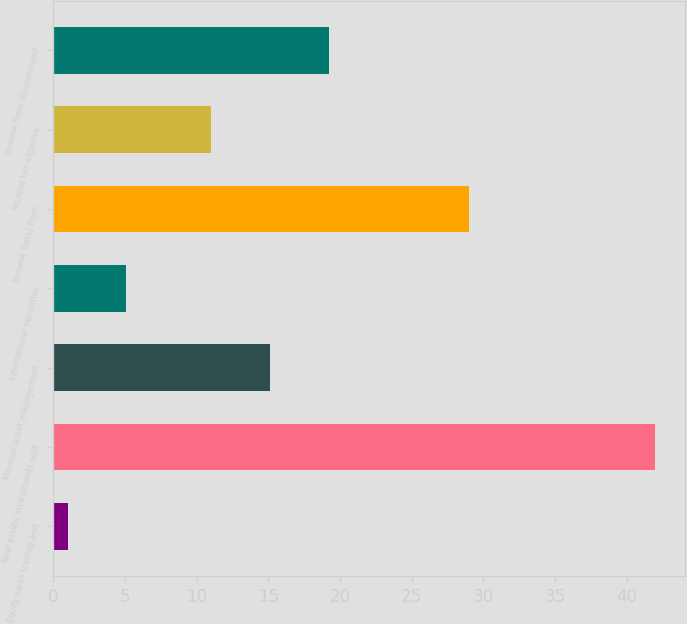Convert chart. <chart><loc_0><loc_0><loc_500><loc_500><bar_chart><fcel>Equity sales trading and<fcel>Real estate investments sold<fcel>Mexican asset management<fcel>International securities<fcel>Income (loss) from<fcel>Income tax expense<fcel>Income from discontinued<nl><fcel>1<fcel>42<fcel>15.1<fcel>5.1<fcel>29<fcel>11<fcel>19.2<nl></chart> 